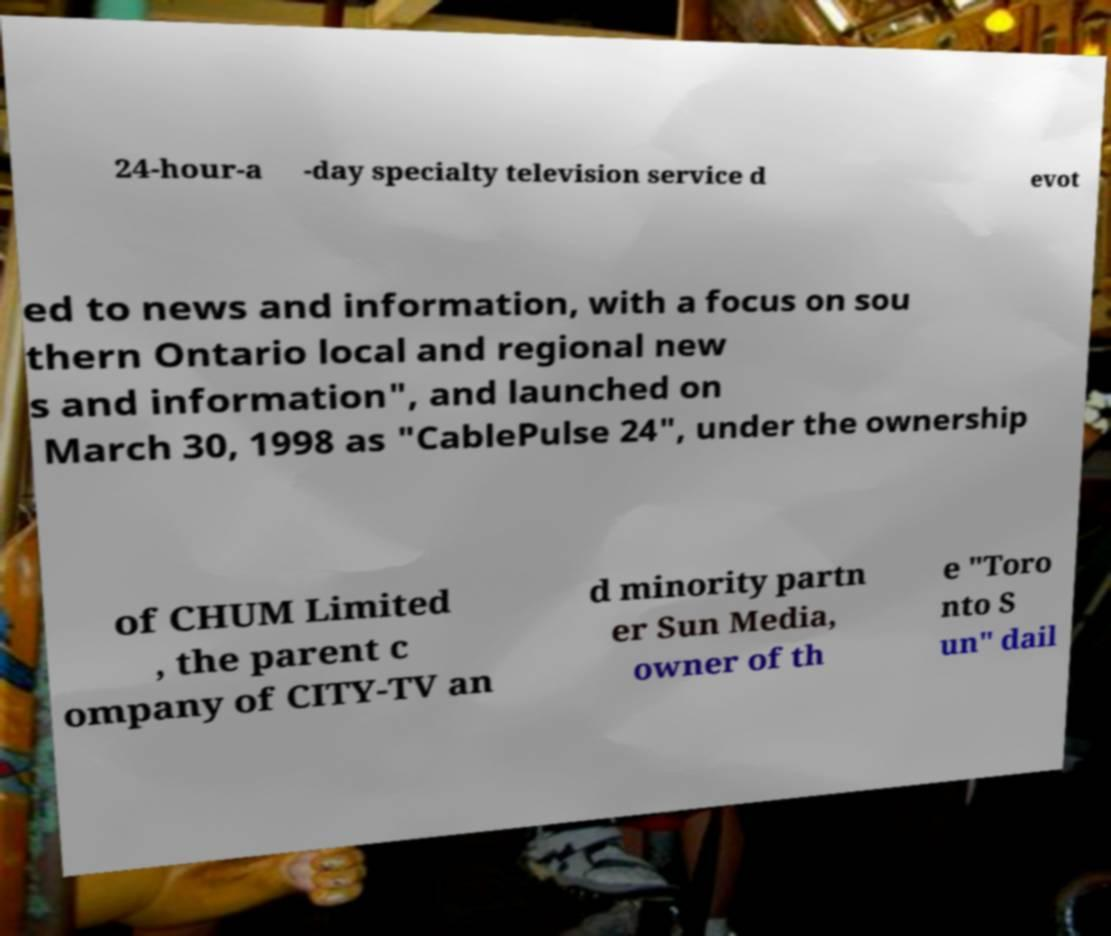What messages or text are displayed in this image? I need them in a readable, typed format. 24-hour-a -day specialty television service d evot ed to news and information, with a focus on sou thern Ontario local and regional new s and information", and launched on March 30, 1998 as "CablePulse 24", under the ownership of CHUM Limited , the parent c ompany of CITY-TV an d minority partn er Sun Media, owner of th e "Toro nto S un" dail 